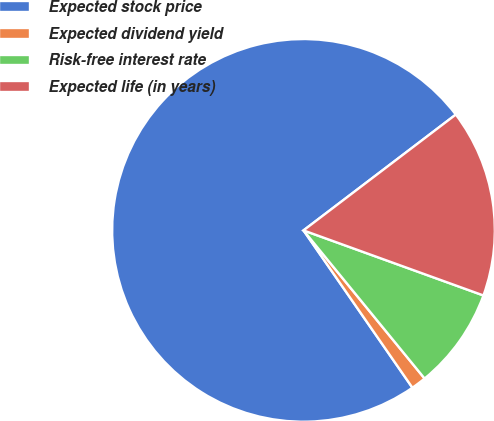Convert chart to OTSL. <chart><loc_0><loc_0><loc_500><loc_500><pie_chart><fcel>Expected stock price<fcel>Expected dividend yield<fcel>Risk-free interest rate<fcel>Expected life (in years)<nl><fcel>74.29%<fcel>1.27%<fcel>8.57%<fcel>15.87%<nl></chart> 